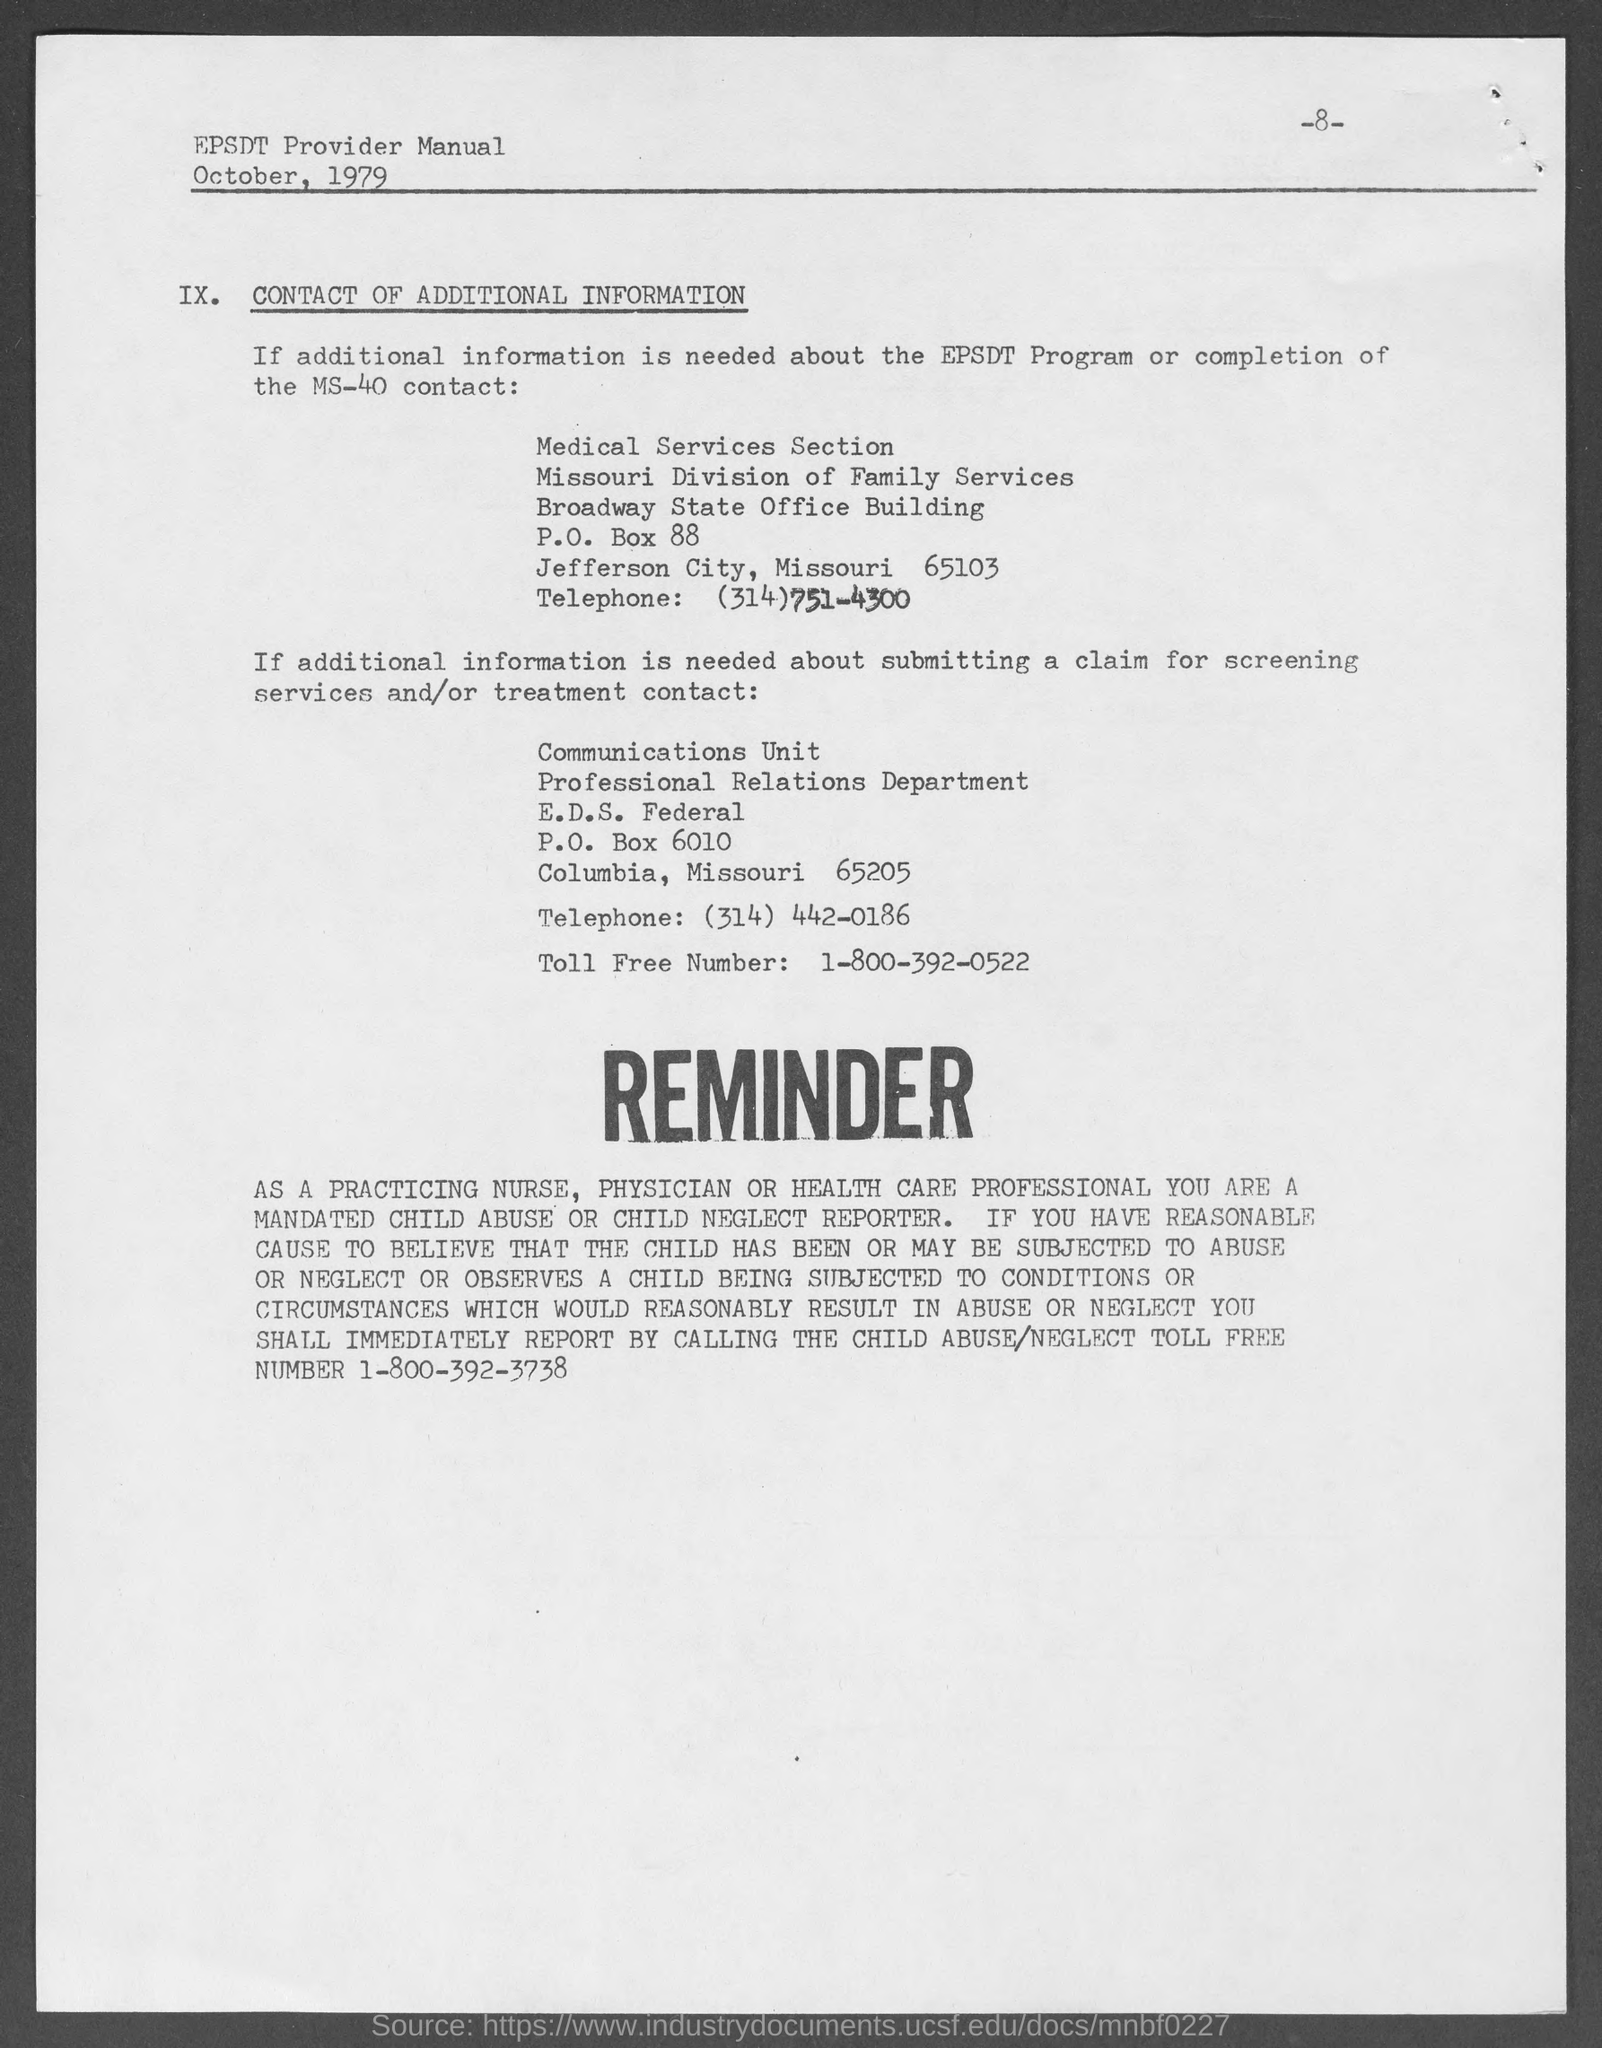Point out several critical features in this image. The toll-free number for reporting cases of child abuse and neglect is 1-800-392-3738. The Professional Relations Department's P.O. number is 6010. The name of the building that houses the Medical Services Section is the Broadway State Office Building. The toll-free number for the Professional Relations Department is 1-800-392-0522. The P.O box number for the Medical Services Section is 88. 